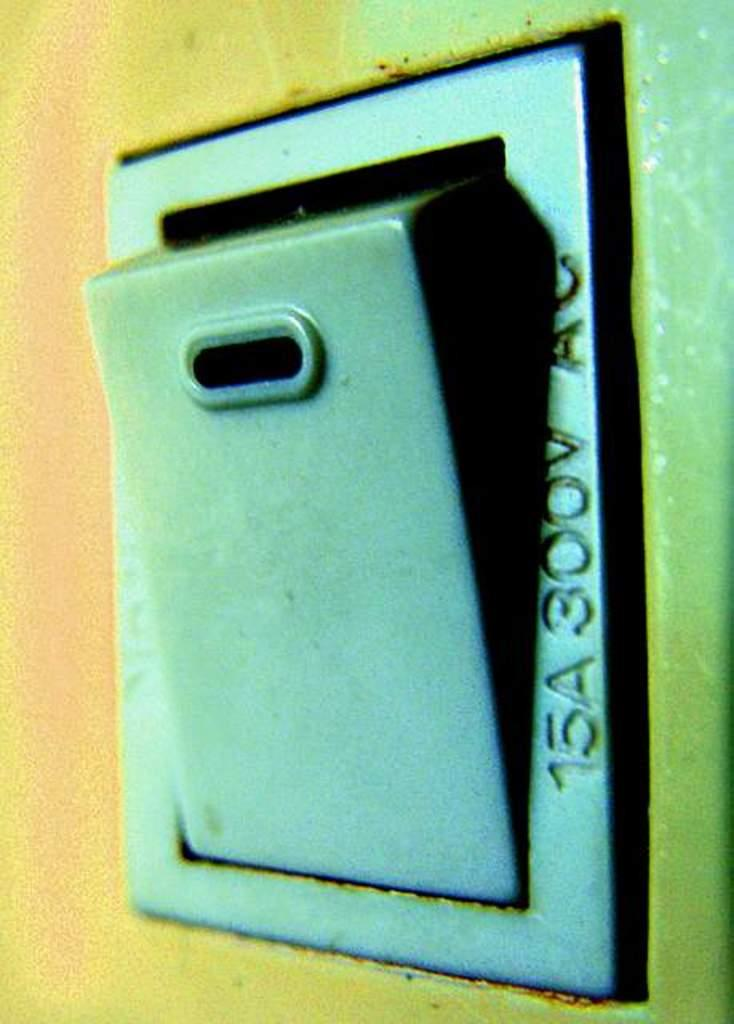<image>
Present a compact description of the photo's key features. A switch with "15A 300V AC" written on it. 